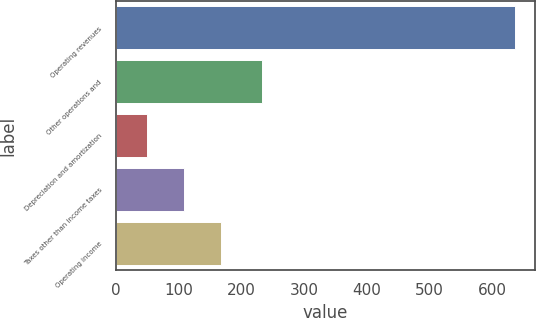Convert chart to OTSL. <chart><loc_0><loc_0><loc_500><loc_500><bar_chart><fcel>Operating revenues<fcel>Other operations and<fcel>Depreciation and amortization<fcel>Taxes other than income taxes<fcel>Operating income<nl><fcel>637<fcel>232<fcel>49<fcel>107.8<fcel>166.6<nl></chart> 